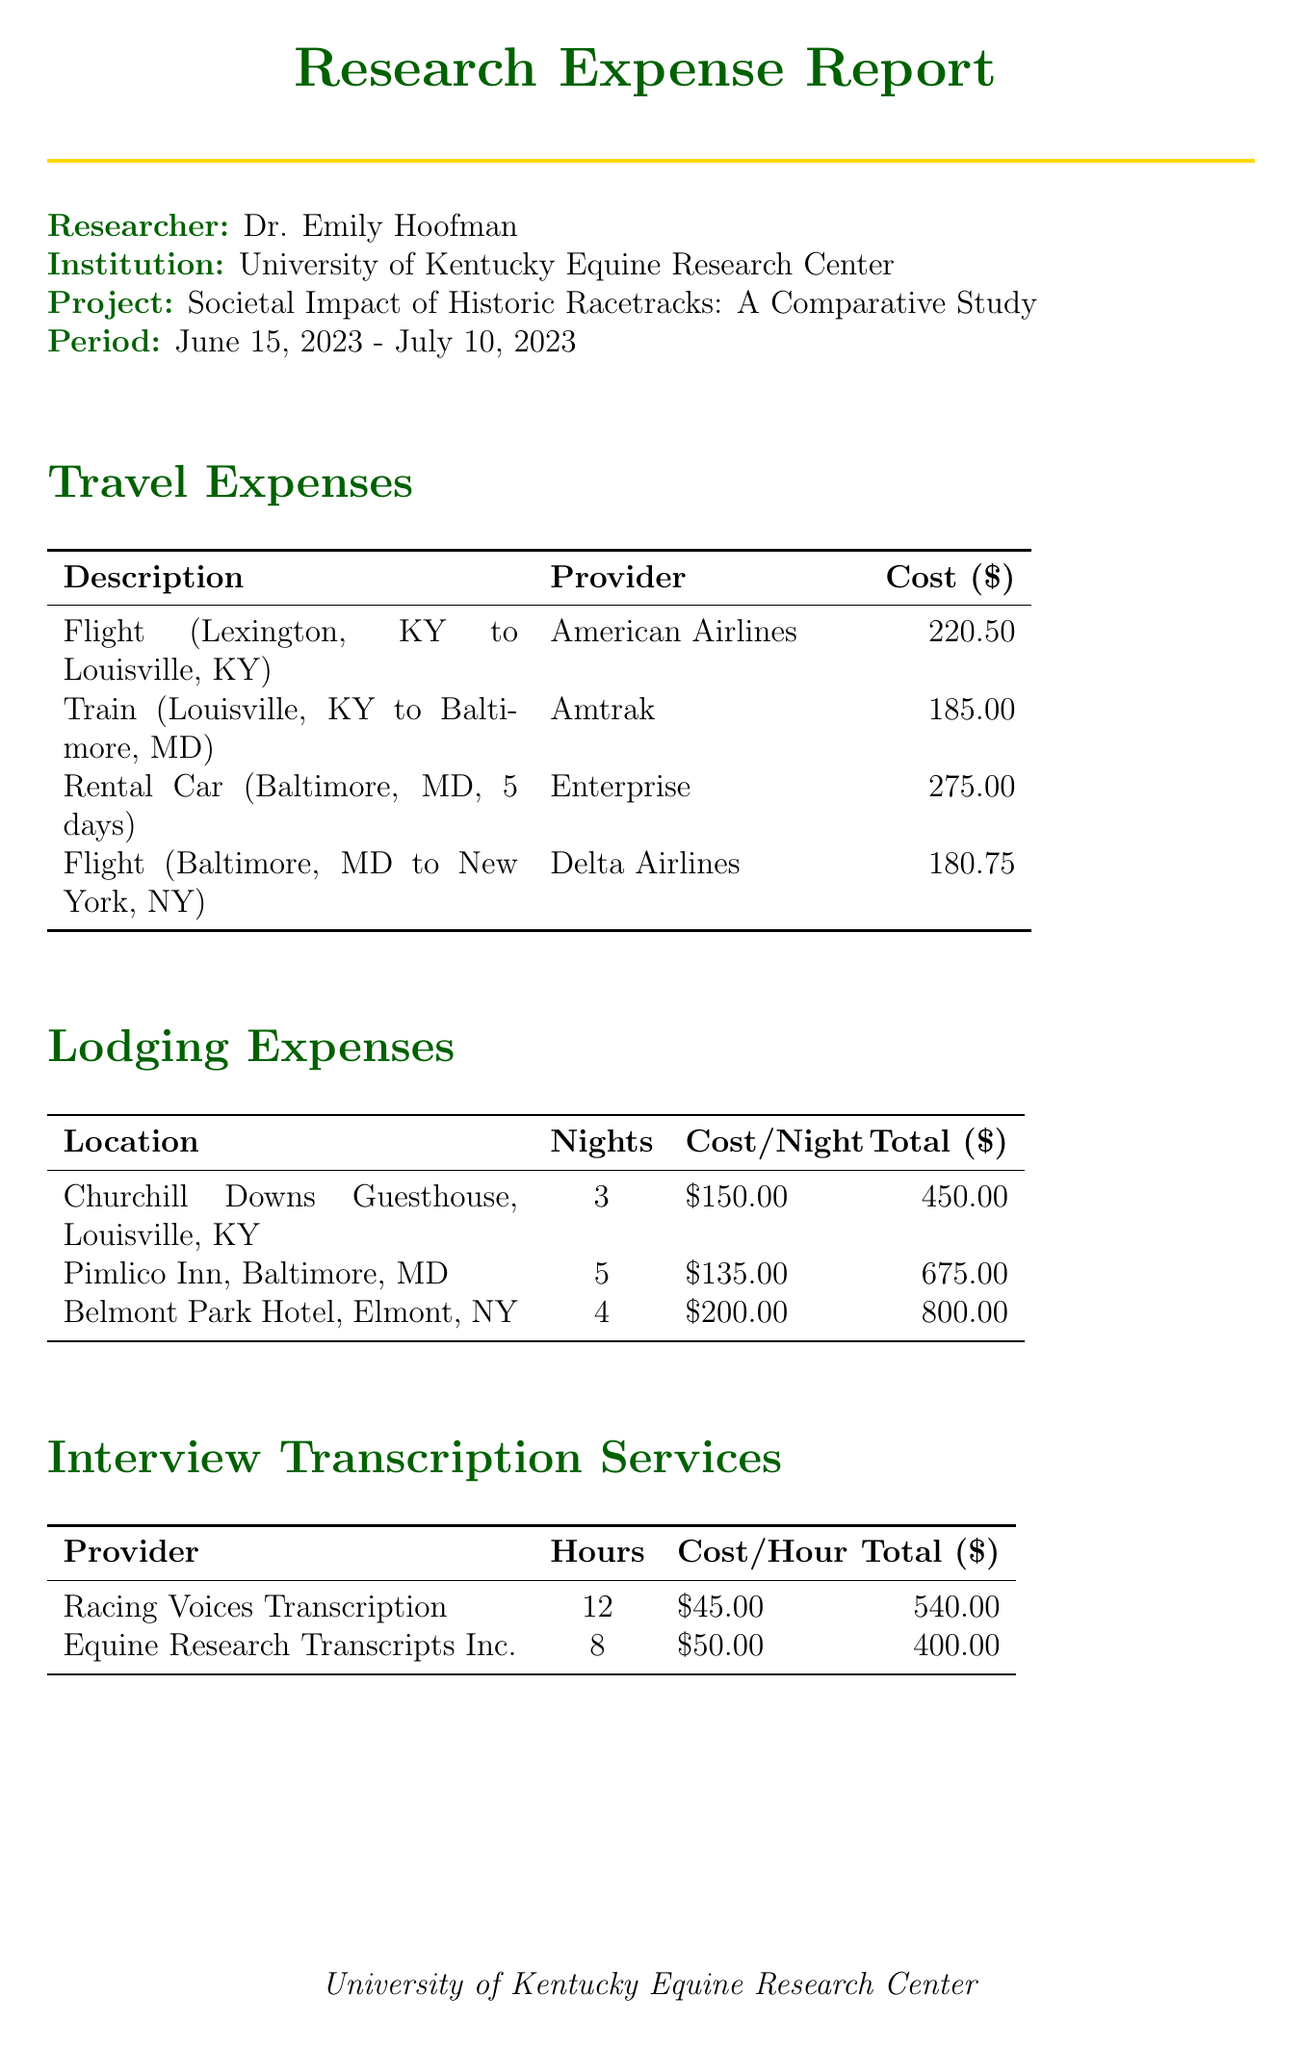what is the researcher’s name? The researcher’s name is listed at the top of the report, identifying the individual responsible for the expenditures.
Answer: Dr. Emily Hoofman what is the total cost of lodging expenses? The total cost of lodging is displayed in the lodging expenses section, calculated as the sum of costs for all locations.
Answer: 1925.00 how many nights did the researcher stay at Pimlico Inn? The number of nights stayed at the Pimlico Inn is detailed in the lodging expenses table.
Answer: 5 what airline was used for the flight from Baltimore to New York? The specific airline for this flight is mentioned in the travel expenses section.
Answer: Delta Airlines how much was spent on meals and incidentals? The cost for meals and incidentals is presented in the miscellaneous expenses section.
Answer: 680.00 who provided the transcription services for 12 hours? The provider of the transcription services is listed along with the associated hours in the interview transcription services section.
Answer: Racing Voices Transcription what is the period of the research project? The period of the project indicates the time frame of the expenses and research activities.
Answer: June 15, 2023 - July 10, 2023 how much did access to the Churchill Downs archives cost? The cost for accessing the Churchill Downs archives is specified in the research materials section.
Answer: 75.00 what is the total amount spent on interview transcription services? The total costs for transcription services are summed up in the interview transcription services section.
Answer: 940.00 